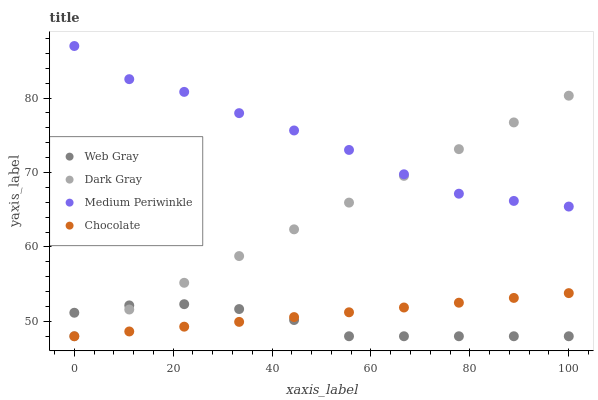Does Web Gray have the minimum area under the curve?
Answer yes or no. Yes. Does Medium Periwinkle have the maximum area under the curve?
Answer yes or no. Yes. Does Medium Periwinkle have the minimum area under the curve?
Answer yes or no. No. Does Web Gray have the maximum area under the curve?
Answer yes or no. No. Is Chocolate the smoothest?
Answer yes or no. Yes. Is Medium Periwinkle the roughest?
Answer yes or no. Yes. Is Web Gray the smoothest?
Answer yes or no. No. Is Web Gray the roughest?
Answer yes or no. No. Does Dark Gray have the lowest value?
Answer yes or no. Yes. Does Medium Periwinkle have the lowest value?
Answer yes or no. No. Does Medium Periwinkle have the highest value?
Answer yes or no. Yes. Does Web Gray have the highest value?
Answer yes or no. No. Is Web Gray less than Medium Periwinkle?
Answer yes or no. Yes. Is Medium Periwinkle greater than Chocolate?
Answer yes or no. Yes. Does Dark Gray intersect Chocolate?
Answer yes or no. Yes. Is Dark Gray less than Chocolate?
Answer yes or no. No. Is Dark Gray greater than Chocolate?
Answer yes or no. No. Does Web Gray intersect Medium Periwinkle?
Answer yes or no. No. 